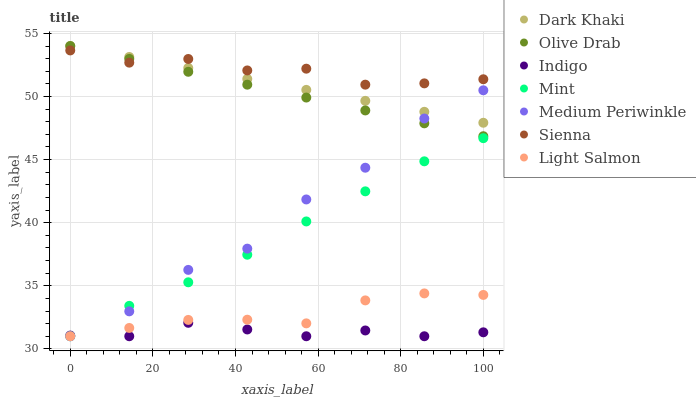Does Indigo have the minimum area under the curve?
Answer yes or no. Yes. Does Sienna have the maximum area under the curve?
Answer yes or no. Yes. Does Light Salmon have the minimum area under the curve?
Answer yes or no. No. Does Light Salmon have the maximum area under the curve?
Answer yes or no. No. Is Olive Drab the smoothest?
Answer yes or no. Yes. Is Medium Periwinkle the roughest?
Answer yes or no. Yes. Is Light Salmon the smoothest?
Answer yes or no. No. Is Light Salmon the roughest?
Answer yes or no. No. Does Light Salmon have the lowest value?
Answer yes or no. Yes. Does Dark Khaki have the lowest value?
Answer yes or no. No. Does Olive Drab have the highest value?
Answer yes or no. Yes. Does Light Salmon have the highest value?
Answer yes or no. No. Is Light Salmon less than Olive Drab?
Answer yes or no. Yes. Is Sienna greater than Indigo?
Answer yes or no. Yes. Does Sienna intersect Dark Khaki?
Answer yes or no. Yes. Is Sienna less than Dark Khaki?
Answer yes or no. No. Is Sienna greater than Dark Khaki?
Answer yes or no. No. Does Light Salmon intersect Olive Drab?
Answer yes or no. No. 